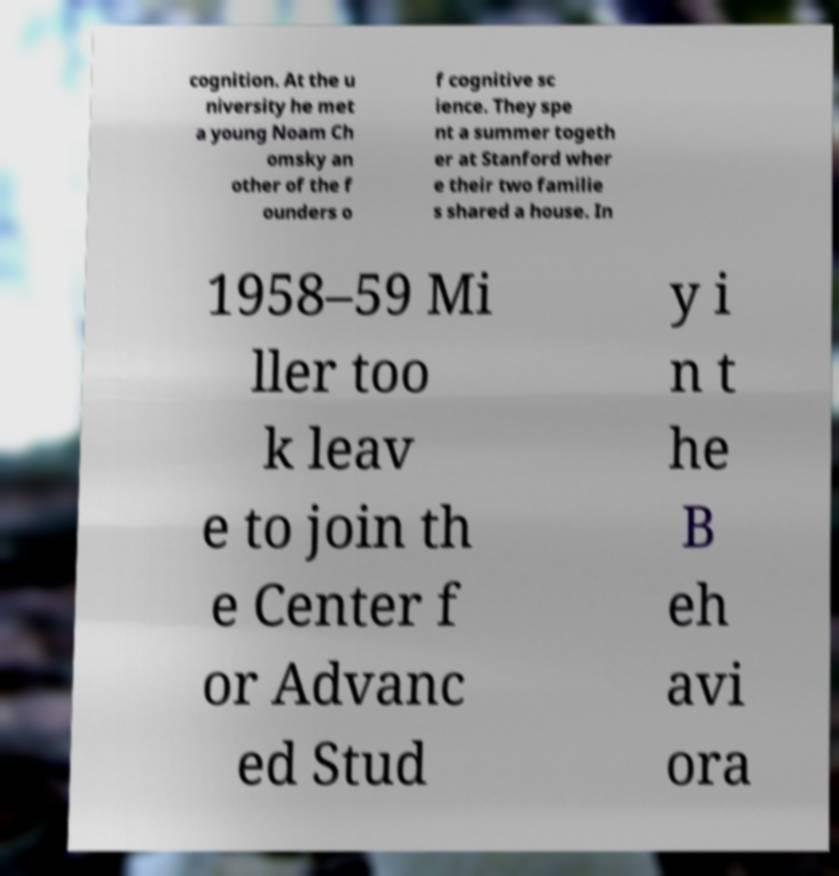Please identify and transcribe the text found in this image. cognition. At the u niversity he met a young Noam Ch omsky an other of the f ounders o f cognitive sc ience. They spe nt a summer togeth er at Stanford wher e their two familie s shared a house. In 1958–59 Mi ller too k leav e to join th e Center f or Advanc ed Stud y i n t he B eh avi ora 